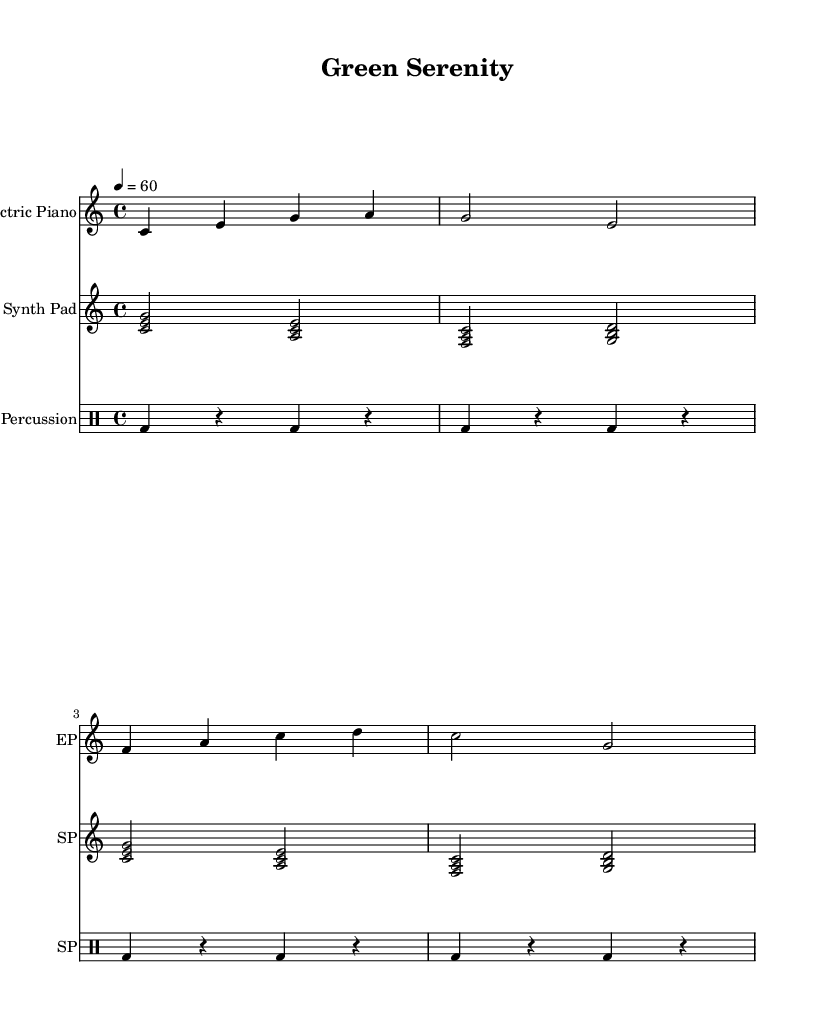What is the key signature of this music? The key signature is C major, which has no sharps or flats.
Answer: C major What is the time signature of this music? The time signature is indicated at the beginning, which is 4/4, meaning there are four beats per measure.
Answer: 4/4 What is the tempo of this piece? The tempo marking indicates a speed of quarter note equals 60 beats per minute, suggesting a slow and relaxing pace.
Answer: 60 How many measures are in the Electric Piano part? The Electric Piano part consists of four measures as indicated by the grouping of notes along the staff.
Answer: 4 Which instruments are used in this piece? The score includes three instruments: Electric Piano, Synth Pad, and Soft Percussion, each labeled at the start of their respective staves.
Answer: Electric Piano, Synth Pad, Soft Percussion What is the rhythmic pattern of the Soft Percussion? The Soft Percussion part features a steady pattern of bass drum hits, alternating with rests, creating a regular four-beat structure in each measure.
Answer: Steady bass drum pattern What chords are used in the Synth Pad part? The Synth Pad part consists of these chord triads: C major, A minor, F major, and G major, which are built on the notes shown in the respective measures.
Answer: C, A minor, F, G 